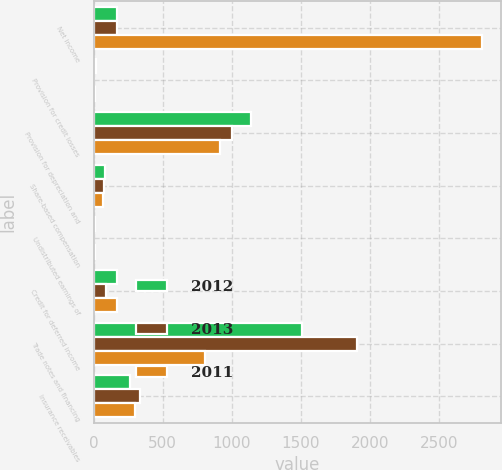<chart> <loc_0><loc_0><loc_500><loc_500><stacked_bar_chart><ecel><fcel>Net income<fcel>Provision for credit losses<fcel>Provision for depreciation and<fcel>Share-based compensation<fcel>Undistributed earnings of<fcel>Credit for deferred income<fcel>Trade notes and financing<fcel>Insurance receivables<nl><fcel>2012<fcel>170.3<fcel>20.5<fcel>1140.3<fcel>80.7<fcel>9.1<fcel>172.6<fcel>1510.2<fcel>263.4<nl><fcel>2013<fcel>170.3<fcel>5.1<fcel>1004.2<fcel>74.5<fcel>1.8<fcel>91.8<fcel>1901.6<fcel>338.5<nl><fcel>2011<fcel>2807.8<fcel>13.5<fcel>914.9<fcel>69<fcel>11.1<fcel>168<fcel>808.9<fcel>300.1<nl></chart> 